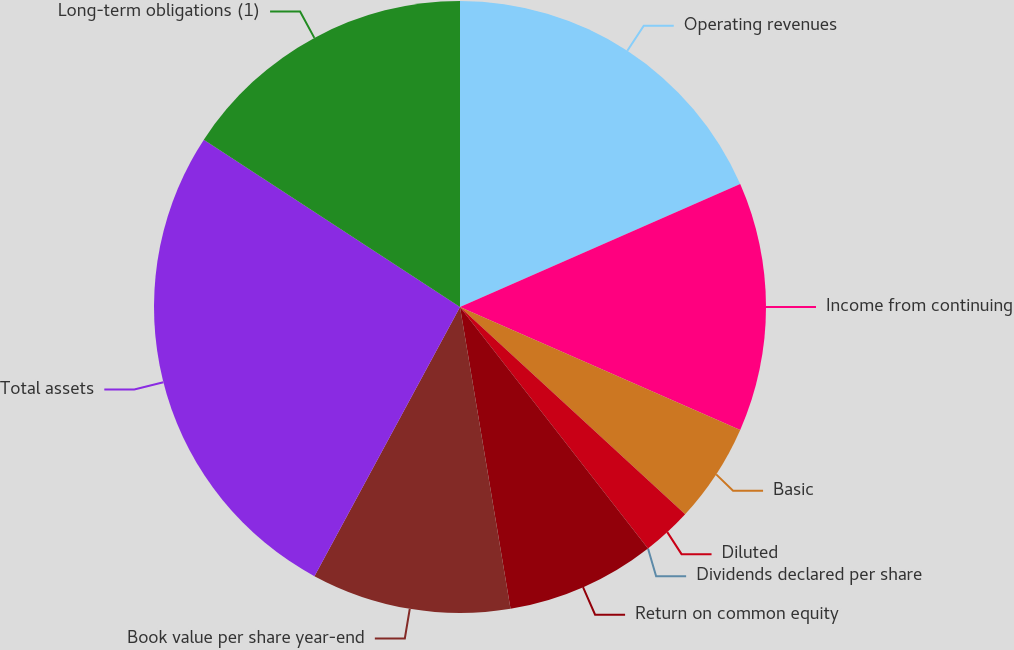Convert chart to OTSL. <chart><loc_0><loc_0><loc_500><loc_500><pie_chart><fcel>Operating revenues<fcel>Income from continuing<fcel>Basic<fcel>Diluted<fcel>Dividends declared per share<fcel>Return on common equity<fcel>Book value per share year-end<fcel>Total assets<fcel>Long-term obligations (1)<nl><fcel>18.42%<fcel>13.16%<fcel>5.26%<fcel>2.63%<fcel>0.0%<fcel>7.89%<fcel>10.53%<fcel>26.32%<fcel>15.79%<nl></chart> 